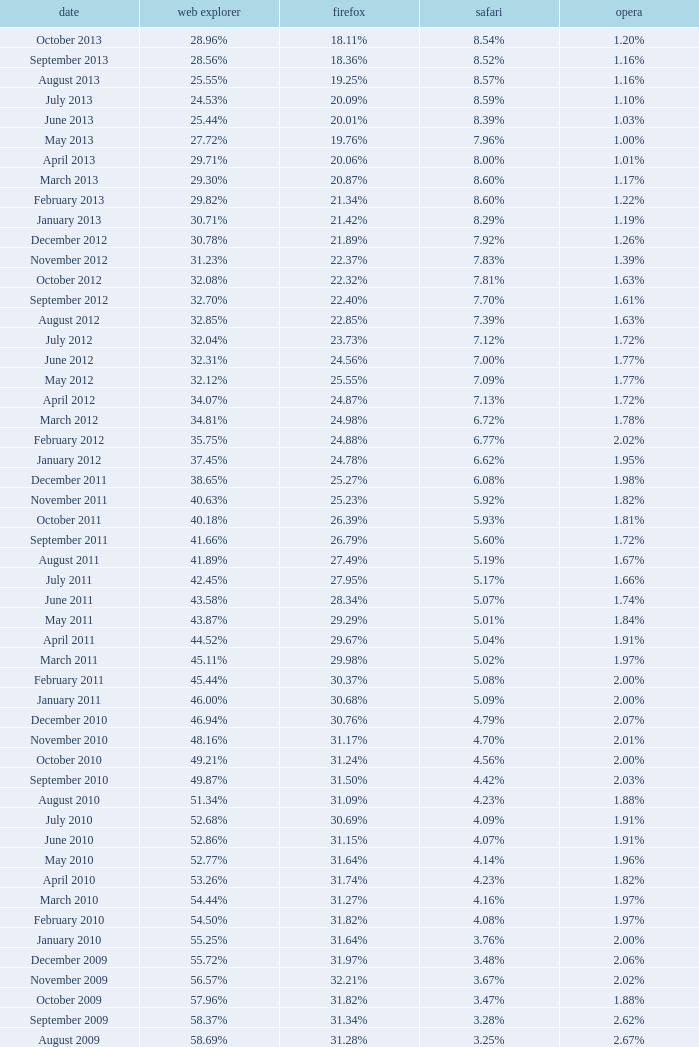What percentage of browsers were using Opera in November 2009? 2.02%. 